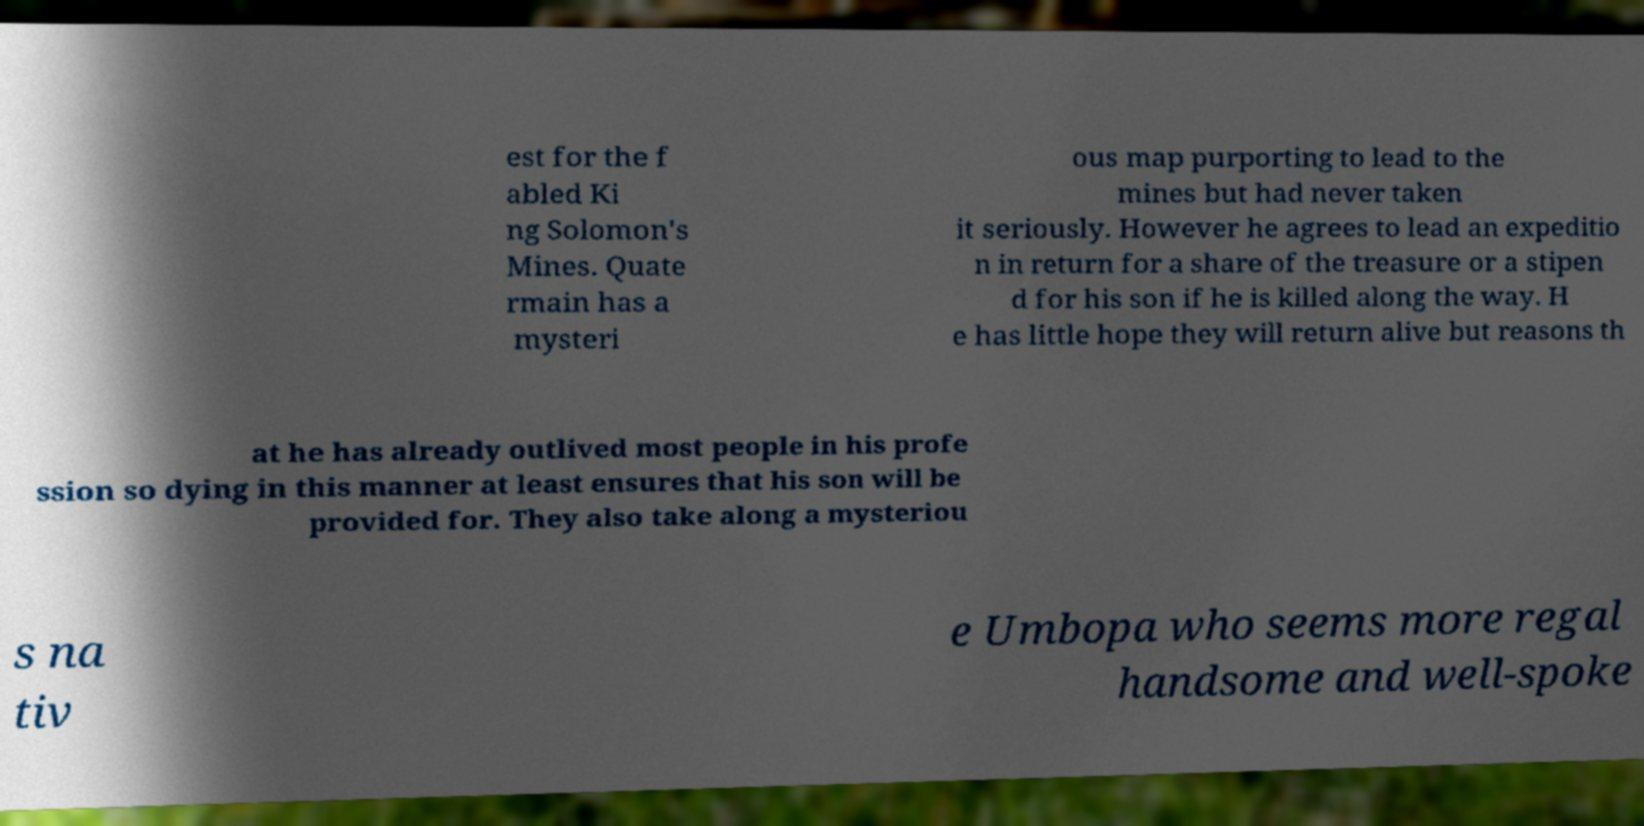What messages or text are displayed in this image? I need them in a readable, typed format. est for the f abled Ki ng Solomon's Mines. Quate rmain has a mysteri ous map purporting to lead to the mines but had never taken it seriously. However he agrees to lead an expeditio n in return for a share of the treasure or a stipen d for his son if he is killed along the way. H e has little hope they will return alive but reasons th at he has already outlived most people in his profe ssion so dying in this manner at least ensures that his son will be provided for. They also take along a mysteriou s na tiv e Umbopa who seems more regal handsome and well-spoke 